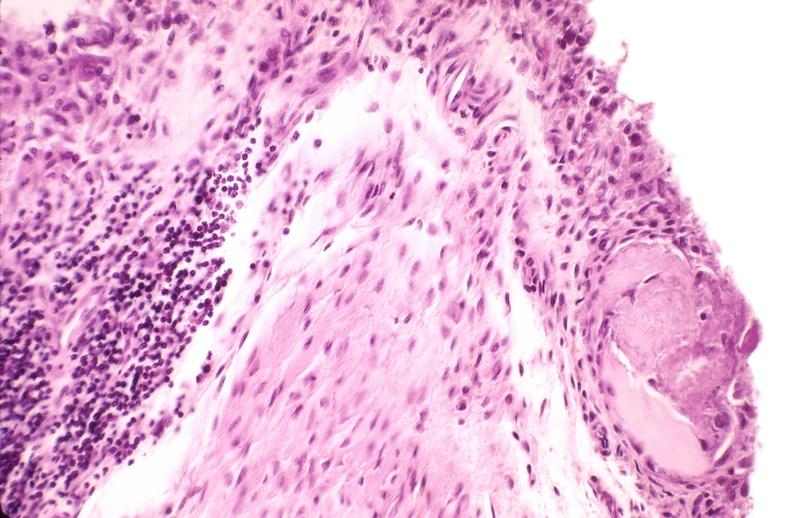s joints present?
Answer the question using a single word or phrase. Yes 